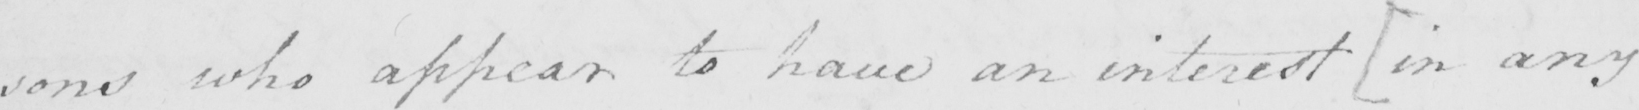What is written in this line of handwriting? : sons who appear to have an interest  [ in any 